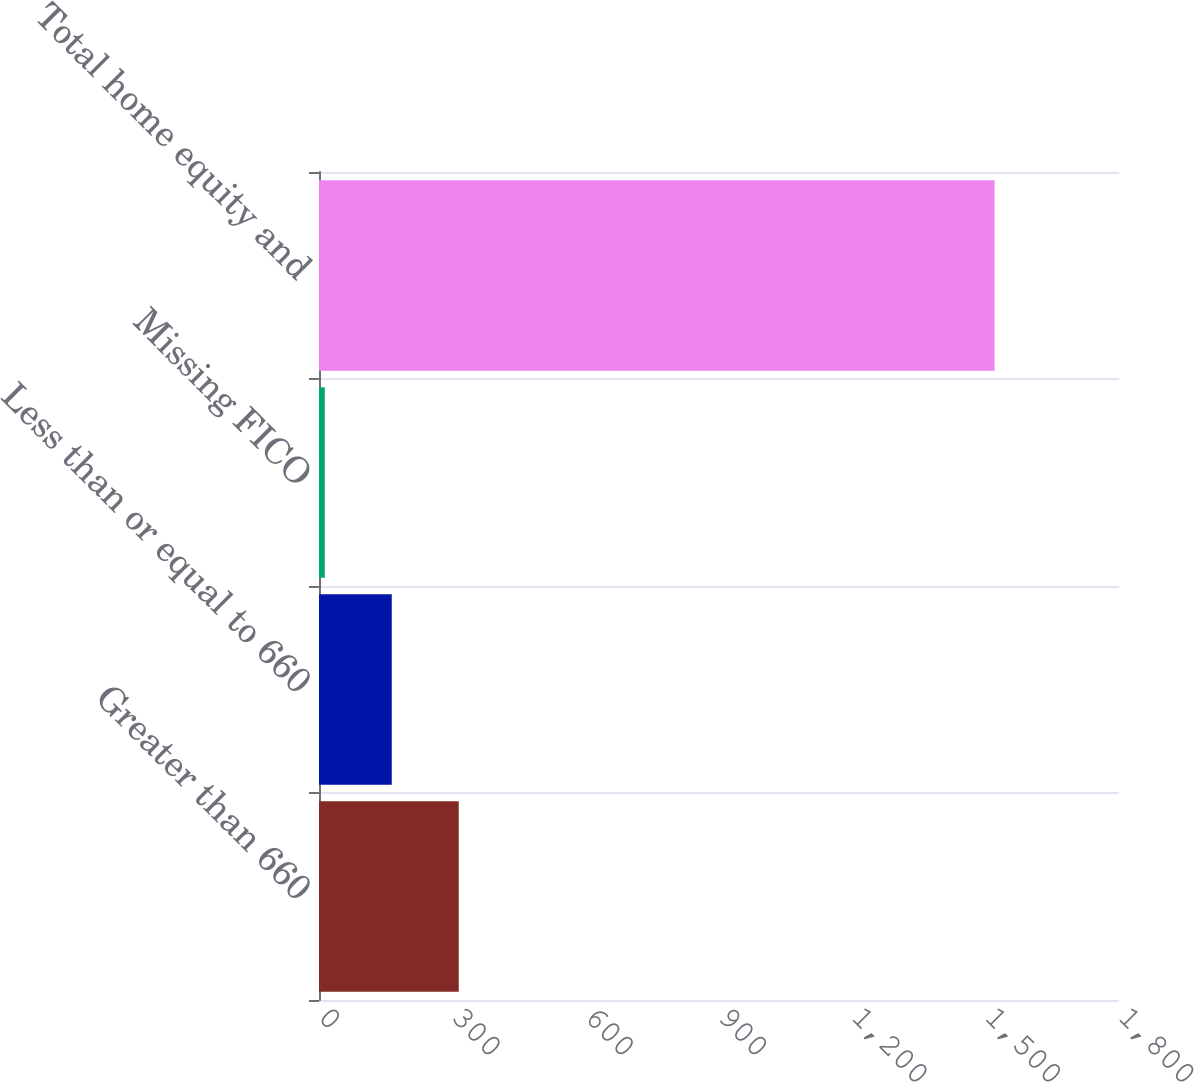<chart> <loc_0><loc_0><loc_500><loc_500><bar_chart><fcel>Greater than 660<fcel>Less than or equal to 660<fcel>Missing FICO<fcel>Total home equity and<nl><fcel>314.4<fcel>163.7<fcel>13<fcel>1520<nl></chart> 